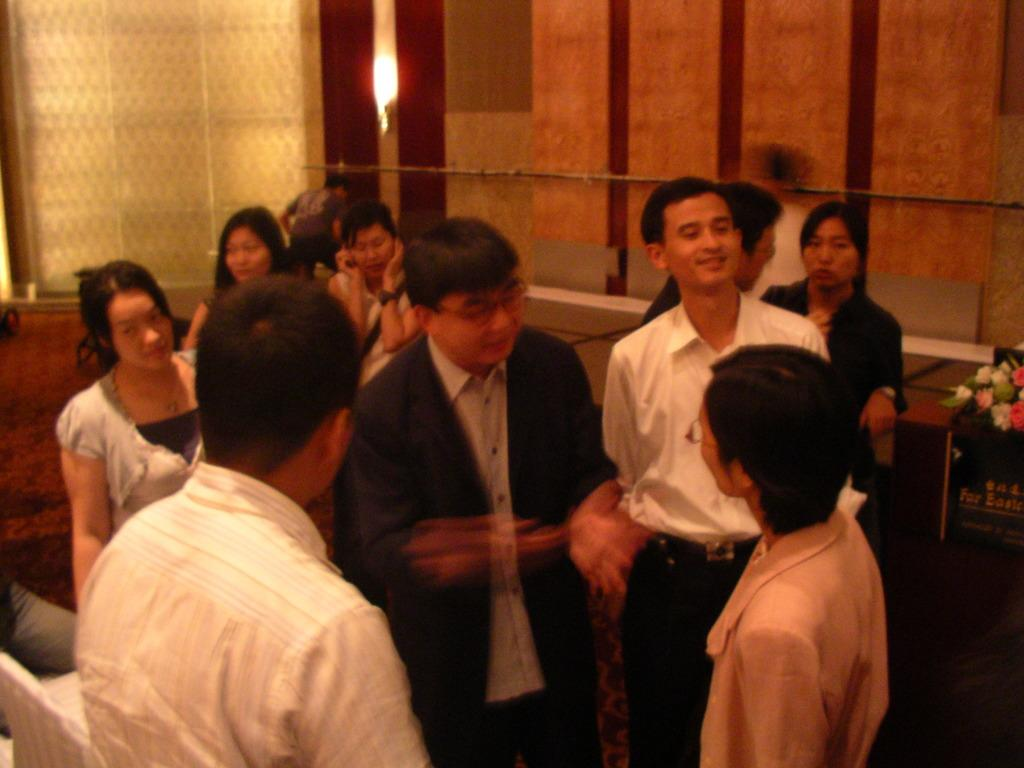How many people are in the image? There is a group of people in the image. Can you describe the attire of one of the individuals? There is a person wearing a black blazer and white shirt in the image. What type of wall can be seen in the background of the image? There is a wooden wall in the background of the image. What is the material of the wall on the right side of the image? There is a glass wall on the right side of the image. Reasoning: Let' Let's think step by step in order to produce the conversation. We start by identifying the main subject in the image, which is the group of people. Then, we expand the conversation to include specific details about one of the individuals and the walls in the background and on the right side of the image. Each question is designed to elicit a specific detail about the image that is known from the provided facts. Absurd Question/Answer: What type of meat is being served on the canvas in the image? There is no meat or canvas present in the image. 